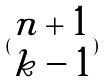Convert formula to latex. <formula><loc_0><loc_0><loc_500><loc_500>( \begin{matrix} n + 1 \\ k - 1 \end{matrix} )</formula> 